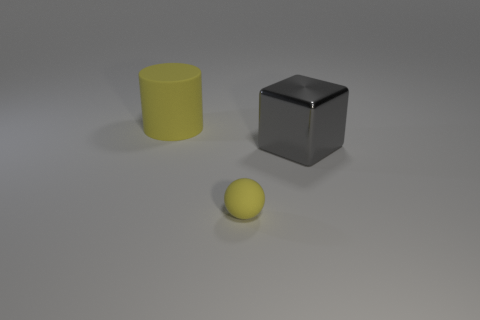Can you tell me the colors of the objects? Certainly! In the image, we see three objects with distinct colors. The large cube in the center has a neutral gray tone, the cylindrical object on the left is yellow, and the sphere is also yellow, all with a flat, non-reflective finish. 